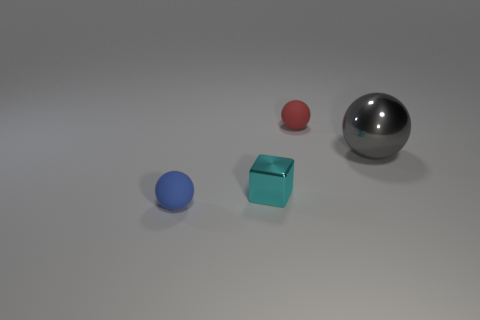Subtract all small rubber spheres. How many spheres are left? 1 Subtract all gray balls. How many balls are left? 2 Subtract all balls. How many objects are left? 1 Subtract 1 cubes. How many cubes are left? 0 Add 4 tiny red matte balls. How many objects exist? 8 Add 3 small blue objects. How many small blue objects are left? 4 Add 2 large blue blocks. How many large blue blocks exist? 2 Subtract 1 gray balls. How many objects are left? 3 Subtract all brown blocks. Subtract all brown spheres. How many blocks are left? 1 Subtract all blue cylinders. How many green spheres are left? 0 